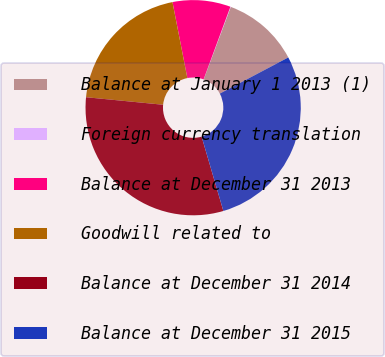Convert chart. <chart><loc_0><loc_0><loc_500><loc_500><pie_chart><fcel>Balance at January 1 2013 (1)<fcel>Foreign currency translation<fcel>Balance at December 31 2013<fcel>Goodwill related to<fcel>Balance at December 31 2014<fcel>Balance at December 31 2015<nl><fcel>11.58%<fcel>0.06%<fcel>8.7%<fcel>20.37%<fcel>31.08%<fcel>28.2%<nl></chart> 